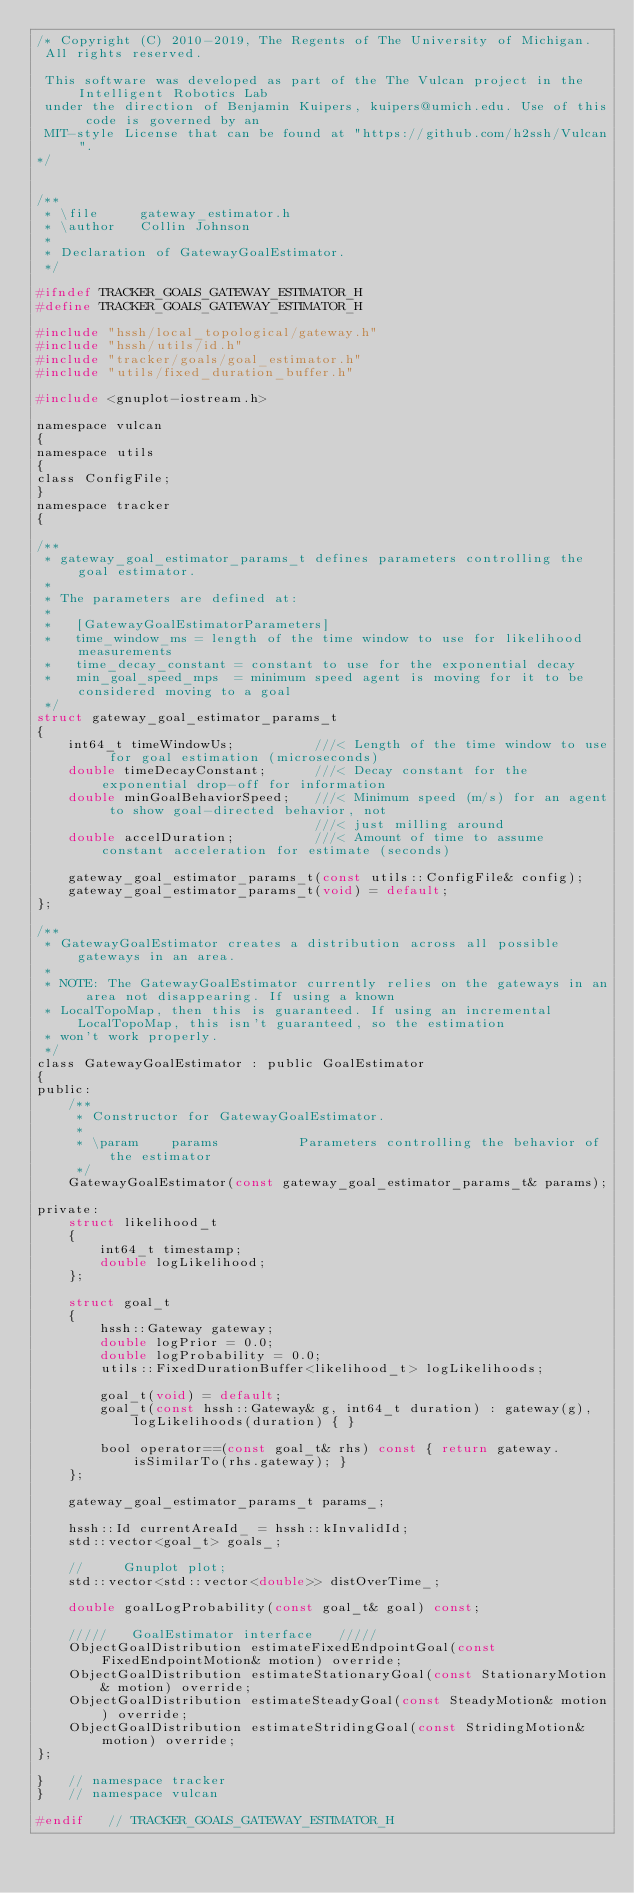Convert code to text. <code><loc_0><loc_0><loc_500><loc_500><_C_>/* Copyright (C) 2010-2019, The Regents of The University of Michigan.
 All rights reserved.

 This software was developed as part of the The Vulcan project in the Intelligent Robotics Lab
 under the direction of Benjamin Kuipers, kuipers@umich.edu. Use of this code is governed by an
 MIT-style License that can be found at "https://github.com/h2ssh/Vulcan".
*/


/**
 * \file     gateway_estimator.h
 * \author   Collin Johnson
 *
 * Declaration of GatewayGoalEstimator.
 */

#ifndef TRACKER_GOALS_GATEWAY_ESTIMATOR_H
#define TRACKER_GOALS_GATEWAY_ESTIMATOR_H

#include "hssh/local_topological/gateway.h"
#include "hssh/utils/id.h"
#include "tracker/goals/goal_estimator.h"
#include "utils/fixed_duration_buffer.h"

#include <gnuplot-iostream.h>

namespace vulcan
{
namespace utils
{
class ConfigFile;
}
namespace tracker
{

/**
 * gateway_goal_estimator_params_t defines parameters controlling the goal estimator.
 *
 * The parameters are defined at:
 *
 *   [GatewayGoalEstimatorParameters]
 *   time_window_ms = length of the time window to use for likelihood measurements
 *   time_decay_constant = constant to use for the exponential decay
 *   min_goal_speed_mps  = minimum speed agent is moving for it to be considered moving to a goal
 */
struct gateway_goal_estimator_params_t
{
    int64_t timeWindowUs;          ///< Length of the time window to use for goal estimation (microseconds)
    double timeDecayConstant;      ///< Decay constant for the exponential drop-off for information
    double minGoalBehaviorSpeed;   ///< Minimum speed (m/s) for an agent to show goal-directed behavior, not
                                   ///< just milling around
    double accelDuration;          ///< Amount of time to assume constant acceleration for estimate (seconds)

    gateway_goal_estimator_params_t(const utils::ConfigFile& config);
    gateway_goal_estimator_params_t(void) = default;
};

/**
 * GatewayGoalEstimator creates a distribution across all possible gateways in an area.
 *
 * NOTE: The GatewayGoalEstimator currently relies on the gateways in an area not disappearing. If using a known
 * LocalTopoMap, then this is guaranteed. If using an incremental LocalTopoMap, this isn't guaranteed, so the estimation
 * won't work properly.
 */
class GatewayGoalEstimator : public GoalEstimator
{
public:
    /**
     * Constructor for GatewayGoalEstimator.
     *
     * \param    params          Parameters controlling the behavior of the estimator
     */
    GatewayGoalEstimator(const gateway_goal_estimator_params_t& params);

private:
    struct likelihood_t
    {
        int64_t timestamp;
        double logLikelihood;
    };

    struct goal_t
    {
        hssh::Gateway gateway;
        double logPrior = 0.0;
        double logProbability = 0.0;
        utils::FixedDurationBuffer<likelihood_t> logLikelihoods;

        goal_t(void) = default;
        goal_t(const hssh::Gateway& g, int64_t duration) : gateway(g), logLikelihoods(duration) { }

        bool operator==(const goal_t& rhs) const { return gateway.isSimilarTo(rhs.gateway); }
    };

    gateway_goal_estimator_params_t params_;

    hssh::Id currentAreaId_ = hssh::kInvalidId;
    std::vector<goal_t> goals_;

    //     Gnuplot plot;
    std::vector<std::vector<double>> distOverTime_;

    double goalLogProbability(const goal_t& goal) const;

    /////   GoalEstimator interface   /////
    ObjectGoalDistribution estimateFixedEndpointGoal(const FixedEndpointMotion& motion) override;
    ObjectGoalDistribution estimateStationaryGoal(const StationaryMotion& motion) override;
    ObjectGoalDistribution estimateSteadyGoal(const SteadyMotion& motion) override;
    ObjectGoalDistribution estimateStridingGoal(const StridingMotion& motion) override;
};

}   // namespace tracker
}   // namespace vulcan

#endif   // TRACKER_GOALS_GATEWAY_ESTIMATOR_H
</code> 